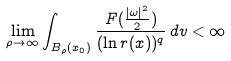Convert formula to latex. <formula><loc_0><loc_0><loc_500><loc_500>\lim _ { \rho \rightarrow \infty } \int _ { B _ { \rho } ( x _ { 0 } ) } \frac { F ( \frac { | \omega | ^ { 2 } } 2 ) } { ( \ln r ( x ) ) ^ { q } } \, d v < \infty</formula> 